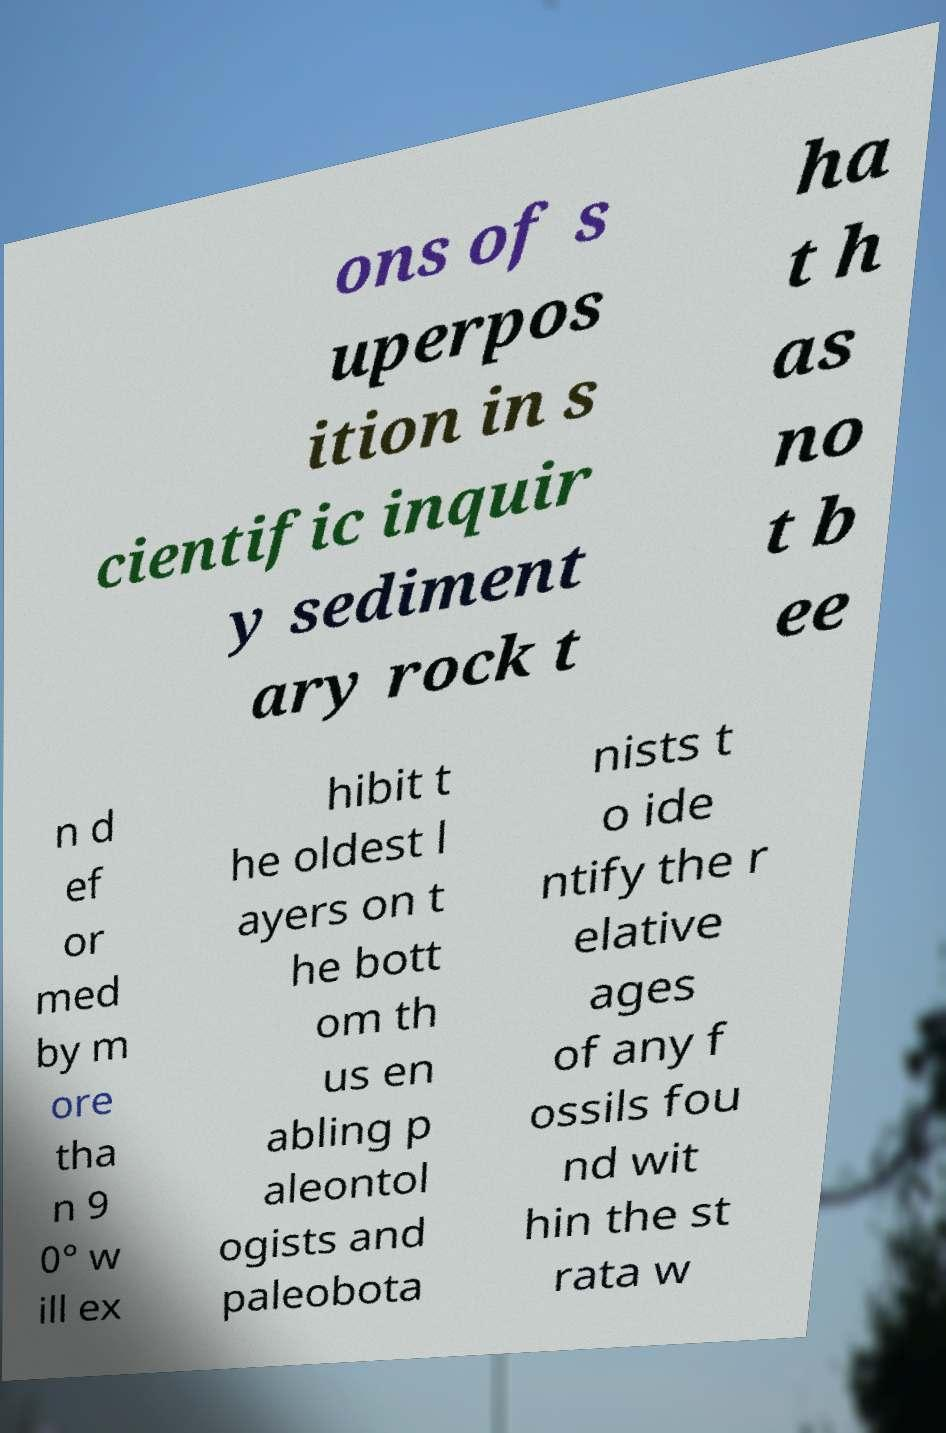I need the written content from this picture converted into text. Can you do that? ons of s uperpos ition in s cientific inquir y sediment ary rock t ha t h as no t b ee n d ef or med by m ore tha n 9 0° w ill ex hibit t he oldest l ayers on t he bott om th us en abling p aleontol ogists and paleobota nists t o ide ntify the r elative ages of any f ossils fou nd wit hin the st rata w 